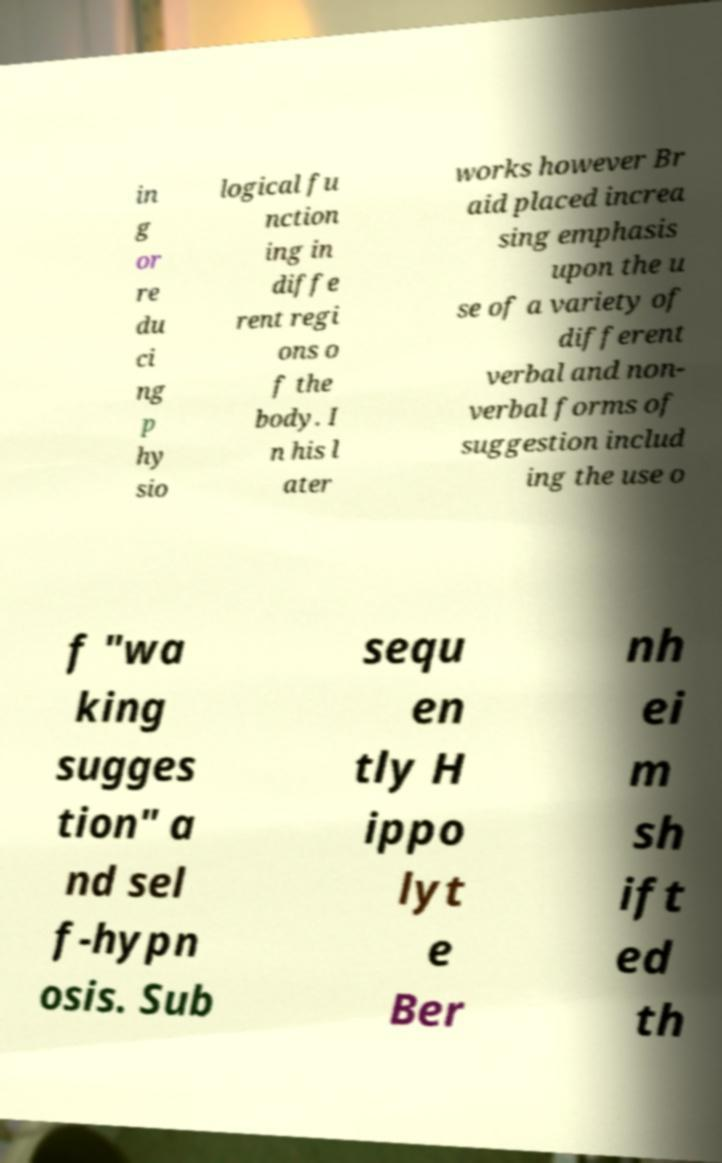Please identify and transcribe the text found in this image. in g or re du ci ng p hy sio logical fu nction ing in diffe rent regi ons o f the body. I n his l ater works however Br aid placed increa sing emphasis upon the u se of a variety of different verbal and non- verbal forms of suggestion includ ing the use o f "wa king sugges tion" a nd sel f-hypn osis. Sub sequ en tly H ippo lyt e Ber nh ei m sh ift ed th 